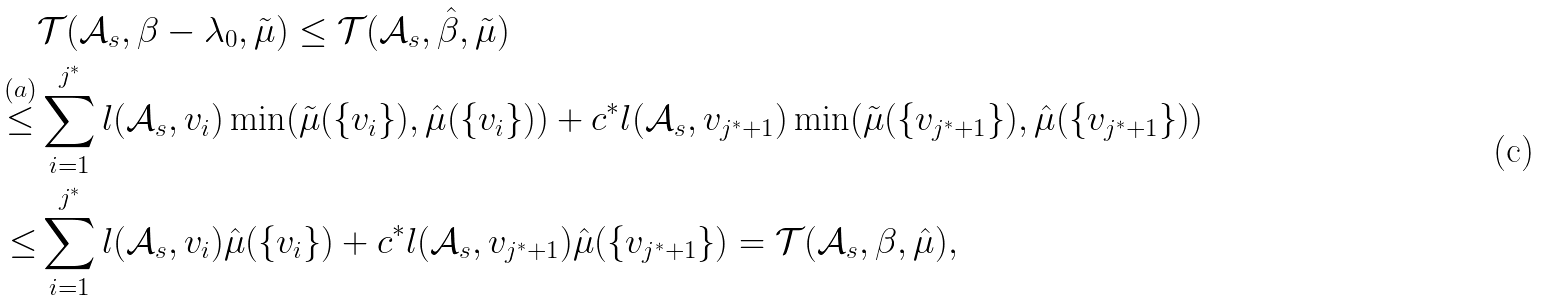Convert formula to latex. <formula><loc_0><loc_0><loc_500><loc_500>& \mathcal { T } ( \mathcal { A } _ { s } , \beta - \lambda _ { 0 } , \tilde { \mu } ) \leq \mathcal { T } ( \mathcal { A } _ { s } , \hat { \beta } , \tilde { \mu } ) \\ \stackrel { ( a ) } { \leq } & \sum _ { i = 1 } ^ { j ^ { * } } l ( \mathcal { A } _ { s } , v _ { i } ) \min ( \tilde { \mu } ( \{ v _ { i } \} ) , \hat { \mu } ( \{ v _ { i } \} ) ) + c ^ { * } l ( \mathcal { A } _ { s } , v _ { j ^ { * } + 1 } ) \min ( \tilde { \mu } ( \{ v _ { j ^ { * } + 1 } \} ) , \hat { \mu } ( \{ v _ { j ^ { * } + 1 } \} ) ) \\ \leq & \sum _ { i = 1 } ^ { j ^ { * } } l ( \mathcal { A } _ { s } , v _ { i } ) \hat { \mu } ( \{ v _ { i } \} ) + c ^ { * } l ( \mathcal { A } _ { s } , v _ { j ^ { * } + 1 } ) \hat { \mu } ( \{ v _ { j ^ { * } + 1 } \} ) = \mathcal { T } ( \mathcal { A } _ { s } , \beta , \hat { \mu } ) ,</formula> 